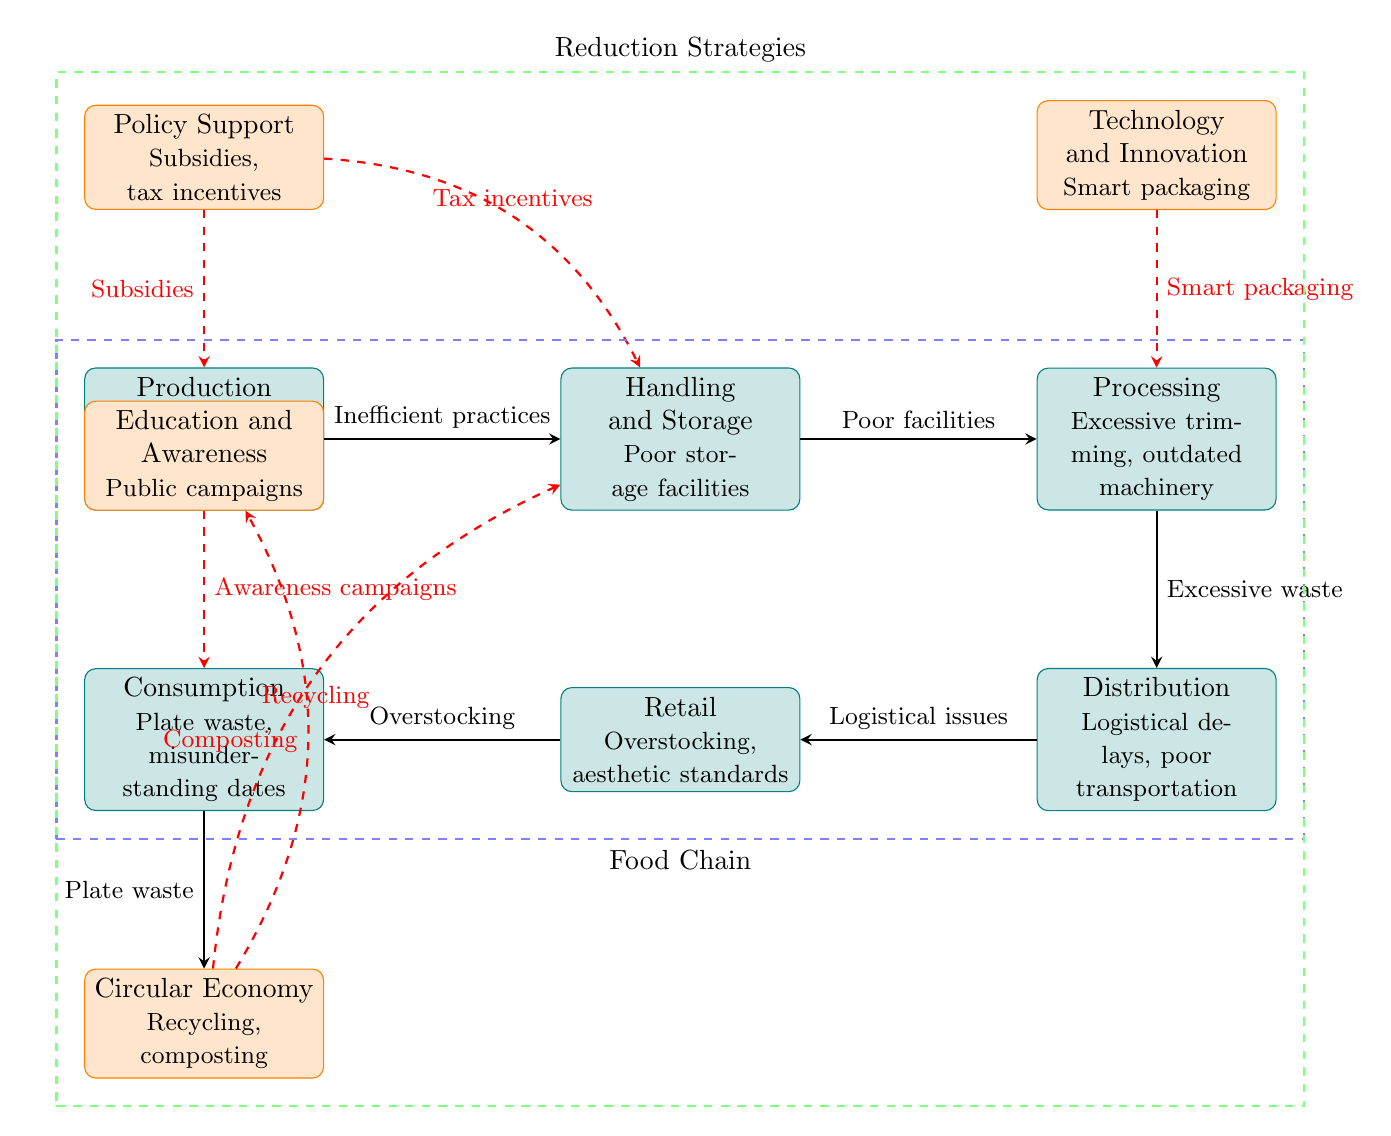What causes waste during the production stage? The diagram indicates that waste during the production stage is caused by inefficient farming practices and overproduction, which are listed below the "Production" node.
Answer: Inefficient farming practices, overproduction How many nodes represent reduction strategies? The diagram has four strategies represented as nodes: Policy Support, Education and Awareness, Technology and Innovation, and Circular Economy. Counting these gives a total of four nodes.
Answer: Four What is the relationship between handling and processing? The diagram shows that "Handling and Storage" leads to "Processing," indicating a direct relationship where handling issues, specifically poor storage facilities, contribute to waste at the processing stage.
Answer: Poor facilities Which stage is linked to composting? The diagram connects the "Consumption" stage to "Circular Economy," which mentions composting as a method to reduce waste, indicating a direct link to this stage.
Answer: Consumption What type of waste occurs during consumption? The diagram specifies that the type of waste during consumption includes plate waste and misunderstanding of expiration dates, as illustrated in the "Consumption" node.
Answer: Plate waste, misunderstanding dates How do education and awareness campaigns reduce waste? The "Education and Awareness" strategy aims to alleviate waste at the consumption stage by promoting awareness campaigns, which help consumers understand food labeling and expiration dates better.
Answer: Awareness campaigns What impacts retail in the food chain? The "Retail" stage is impacted by overstocking and aesthetic standards, which can cause significant waste, as highlighted in the description under the "Retail" node.
Answer: Overstocking, aesthetic standards What is the function of technological innovation in reducing processing waste? The diagram indicates that technological innovation, specifically smart packaging, plays a crucial role in reducing excessive waste during the processing stage by improving efficiency and reducing spoilage.
Answer: Smart packaging How does circular economy relate to production? The "Circular Economy" strategy includes recycling and composting, which ties back to the "Production" stage, indicating that practices like composting can help minimize waste generated during production.
Answer: Composting 